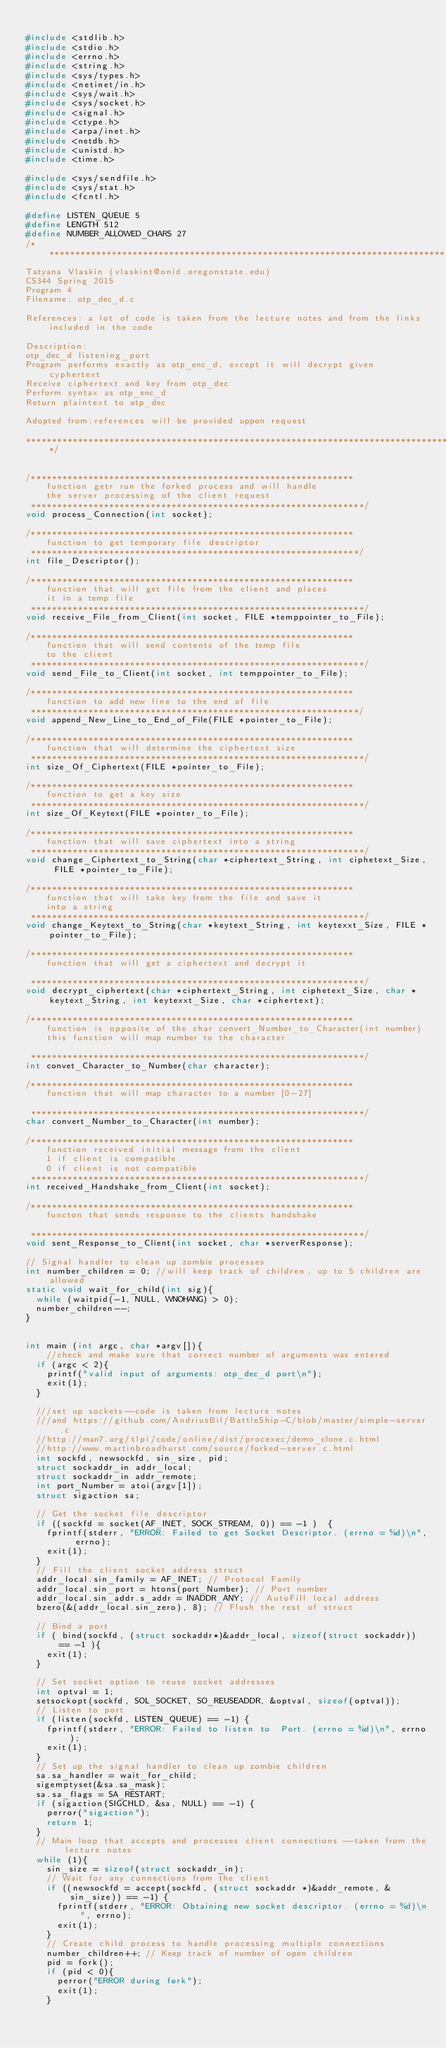Convert code to text. <code><loc_0><loc_0><loc_500><loc_500><_C_>
#include <stdlib.h>
#include <stdio.h>
#include <errno.h>
#include <string.h>
#include <sys/types.h>
#include <netinet/in.h>
#include <sys/wait.h>
#include <sys/socket.h>
#include <signal.h>
#include <ctype.h>
#include <arpa/inet.h>
#include <netdb.h>
#include <unistd.h>
#include <time.h>

#include <sys/sendfile.h>
#include <sys/stat.h>
#include <fcntl.h>

#define LISTEN_QUEUE 5
#define LENGTH 512
#define NUMBER_ALLOWED_CHARS 27
/*********************************************************************************************************************************************
Tatyana Vlaskin (vlaskint@onid.oregonstate.edu)
CS344 Spring 2015
Program 4
Filename: otp_dec_d.c

References: a lot of code is taken from the lecture notes and from the links included in the code

Description:
otp_dec_d listening_port
Program performs exactly as otp_enc_d, except it will decrypt given cyphertext
Receive ciphertext and key from otp_dec
Perform syntax as otp_enc_d
Return plaintext to otp_dec

Adopted from:references will be provided uppon request

**********************************************************************************************************************************************/


/**************************************************************
    function getr run the forked process and will handle
    the server processing of the client request
 ****************************************************************/
void process_Connection(int socket);

/**************************************************************
    function to get temporary file descriptor
 ***************************************************************/
int file_Descriptor();

/**************************************************************
    function that will get file from the client and places
    it in a temp file
 ****************************************************************/
void receive_File_from_Client(int socket, FILE *temppointer_to_File);

/**************************************************************
    function that will send contents of the temp file
    to the client
 ****************************************************************/
void send_File_to_Client(int socket, int temppointer_to_File);

/**************************************************************
    function to add new line to the end of file
 ***************************************************************/
void append_New_Line_to_End_of_File(FILE *pointer_to_File);

/**************************************************************
    function that will determine the ciphertext size
 ****************************************************************/
int size_Of_Ciphertext(FILE *pointer_to_File);

/**************************************************************
    function to get a key size
 ****************************************************************/
int size_Of_Keytext(FILE *pointer_to_File);

/**************************************************************
    function that will save ciphertext into a string
 ****************************************************************/
void change_Ciphertext_to_String(char *ciphertext_String, int ciphetext_Size, FILE *pointer_to_File);

/**************************************************************
    function that will take key from the file and save it
    into a string
 ****************************************************************/
void change_Keytext_to_String(char *keytext_String, int keytexxt_Size, FILE *pointer_to_File);

/**************************************************************
    function that will get a ciphertext and decrypt it

 ****************************************************************/
void decrypt_ciphertext(char *ciphertext_String, int ciphetext_Size, char *keytext_String, int keytexxt_Size, char *ciphertext);

/**************************************************************
    function is opposite of the char convert_Number_to_Character(int number)
    this function will map number to the character

 ****************************************************************/
int convet_Character_to_Number(char character);

/**************************************************************
    function that will map character to a number [0-27]

 ****************************************************************/
char convert_Number_to_Character(int number);

/**************************************************************
    function received initial message from the client
    1 if client is compatible
    0 if client is not compatible
 ****************************************************************/
int received_Handshake_from_Client(int socket);

/**************************************************************
    functon that sends response to the clients handshake

 ****************************************************************/
void sent_Response_to_Client(int socket, char *serverResponse);

// Signal handler to clean up zombie processes
int number_children = 0; //will keep track of children, up to 5 children are allowed
static void wait_for_child(int sig){
	while (waitpid(-1, NULL, WNOHANG) > 0);
	number_children--;
}


int main (int argc, char *argv[]){
    //check and make sure that correct number of arguments was entered
	if (argc < 2){
		printf("valid input of arguments: otp_dec_d port\n");
		exit(1);
	}

	///set up sockets--code is taken from lecture notes
	///and https://github.com/AndriusBil/BattleShip-C/blob/master/simple-server.c
	//http://man7.org/tlpi/code/online/dist/procexec/demo_clone.c.html
	//http://www.martinbroadhurst.com/source/forked-server.c.html
	int sockfd, newsockfd, sin_size, pid;
	struct sockaddr_in addr_local;
	struct sockaddr_in addr_remote;
	int port_Number = atoi(argv[1]);
	struct sigaction sa;

	// Get the socket file descriptor
	if ((sockfd = socket(AF_INET, SOCK_STREAM, 0)) == -1 )	{
		fprintf(stderr, "ERROR: Failed to get Socket Descriptor. (errno = %d)\n", errno);
		exit(1);
	}
	// Fill the client socket address struct
	addr_local.sin_family = AF_INET; // Protocol Family
	addr_local.sin_port = htons(port_Number); // Port number
	addr_local.sin_addr.s_addr = INADDR_ANY; // AutoFill local address
	bzero(&(addr_local.sin_zero), 8); // Flush the rest of struct

	// Bind a port
	if ( bind(sockfd, (struct sockaddr*)&addr_local, sizeof(struct sockaddr)) == -1 ){
		exit(1);
	}

	// Set socket option to reuse socket addresses
	int optval = 1;
	setsockopt(sockfd, SOL_SOCKET, SO_REUSEADDR, &optval, sizeof(optval));
	// Listen to port
	if (listen(sockfd, LISTEN_QUEUE) == -1)	{
		fprintf(stderr, "ERROR: Failed to listen to  Port. (errno = %d)\n", errno);
		exit(1);
	}
	// Set up the signal handler to clean up zombie children
	sa.sa_handler = wait_for_child;
	sigemptyset(&sa.sa_mask);
	sa.sa_flags = SA_RESTART;
	if (sigaction(SIGCHLD, &sa, NULL) == -1) {
		perror("sigaction");
		return 1;
	}
	// Main loop that accepts and processes client connections --taken from the lecture notes
	while (1){
		sin_size = sizeof(struct sockaddr_in);
		// Wait for any connections from the client
		if ((newsockfd = accept(sockfd, (struct sockaddr *)&addr_remote, &sin_size)) == -1)	{
			fprintf(stderr, "ERROR: Obtaining new socket descriptor. (errno = %d)\n", errno);
			exit(1);
		}
		// Create child process to handle processing multiple connections
		number_children++; // Keep track of number of open children
		pid = fork();
		if (pid < 0){
			perror("ERROR during fork");
			exit(1);
		}</code> 